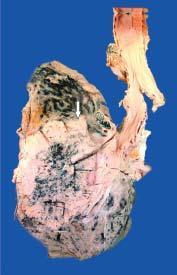sectioned surface shows grey-white fleshy tumour in the bronchus at whose bifurcation?
Answer the question using a single word or phrase. Its 